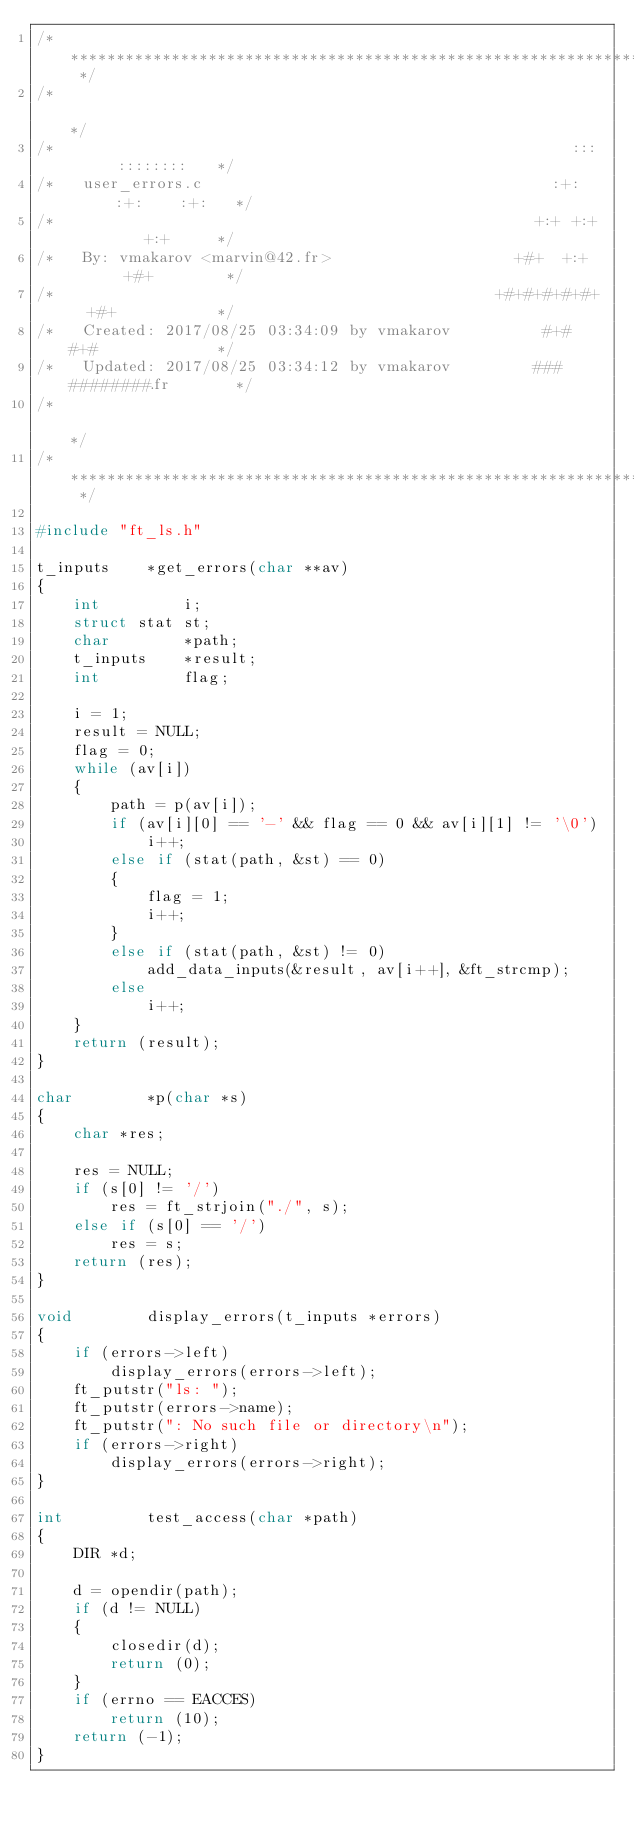Convert code to text. <code><loc_0><loc_0><loc_500><loc_500><_C_>/* ************************************************************************** */
/*                                                                            */
/*                                                        :::      ::::::::   */
/*   user_errors.c                                      :+:      :+:    :+:   */
/*                                                    +:+ +:+         +:+     */
/*   By: vmakarov <marvin@42.fr>                    +#+  +:+       +#+        */
/*                                                +#+#+#+#+#+   +#+           */
/*   Created: 2017/08/25 03:34:09 by vmakarov          #+#    #+#             */
/*   Updated: 2017/08/25 03:34:12 by vmakarov         ###   ########.fr       */
/*                                                                            */
/* ************************************************************************** */

#include "ft_ls.h"

t_inputs	*get_errors(char **av)
{
	int			i;
	struct stat	st;
	char		*path;
	t_inputs	*result;
	int			flag;

	i = 1;
	result = NULL;
	flag = 0;
	while (av[i])
	{
		path = p(av[i]);
		if (av[i][0] == '-' && flag == 0 && av[i][1] != '\0')
			i++;
		else if (stat(path, &st) == 0)
		{
			flag = 1;
			i++;
		}
		else if (stat(path, &st) != 0)
			add_data_inputs(&result, av[i++], &ft_strcmp);
		else
			i++;
	}
	return (result);
}

char		*p(char *s)
{
	char *res;

	res = NULL;
	if (s[0] != '/')
		res = ft_strjoin("./", s);
	else if (s[0] == '/')
		res = s;
	return (res);
}

void		display_errors(t_inputs *errors)
{
	if (errors->left)
		display_errors(errors->left);
	ft_putstr("ls: ");
	ft_putstr(errors->name);
	ft_putstr(": No such file or directory\n");
	if (errors->right)
		display_errors(errors->right);
}

int			test_access(char *path)
{
	DIR *d;

	d = opendir(path);
	if (d != NULL)
	{
		closedir(d);
		return (0);
	}
	if (errno == EACCES)
		return (10);
	return (-1);
}
</code> 